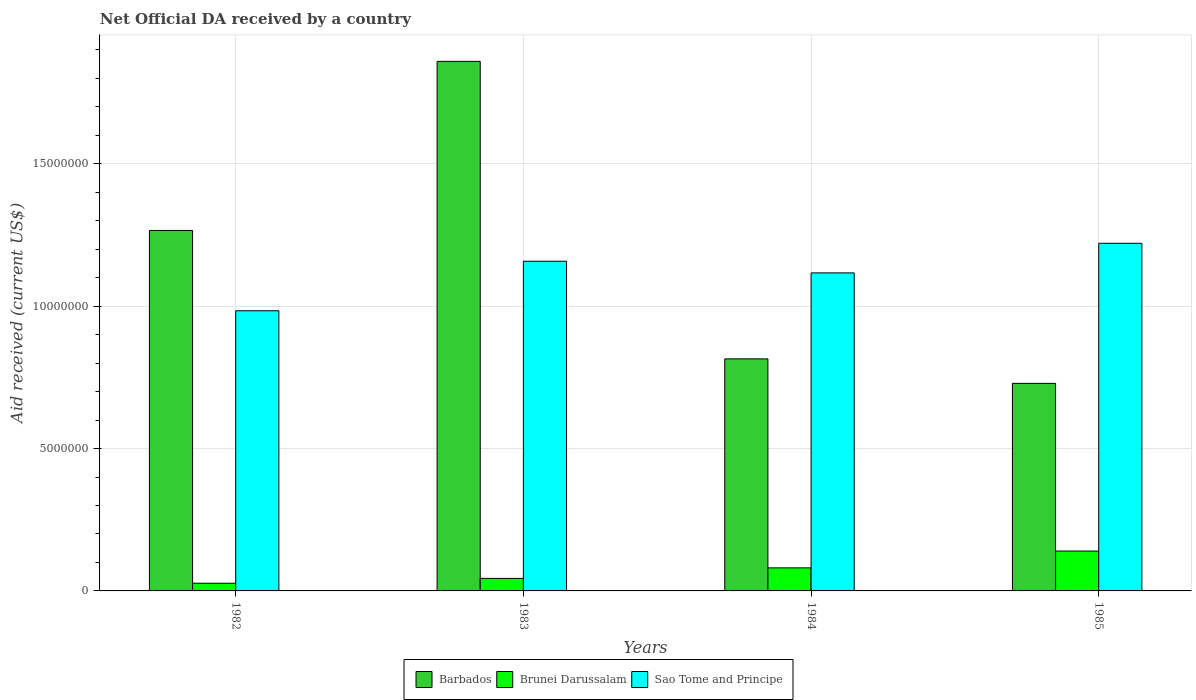How many groups of bars are there?
Provide a short and direct response. 4. Are the number of bars on each tick of the X-axis equal?
Offer a very short reply. Yes. What is the net official development assistance aid received in Brunei Darussalam in 1985?
Provide a short and direct response. 1.40e+06. Across all years, what is the maximum net official development assistance aid received in Brunei Darussalam?
Keep it short and to the point. 1.40e+06. Across all years, what is the minimum net official development assistance aid received in Barbados?
Give a very brief answer. 7.29e+06. In which year was the net official development assistance aid received in Barbados maximum?
Ensure brevity in your answer.  1983. In which year was the net official development assistance aid received in Barbados minimum?
Your answer should be very brief. 1985. What is the total net official development assistance aid received in Sao Tome and Principe in the graph?
Provide a short and direct response. 4.48e+07. What is the difference between the net official development assistance aid received in Brunei Darussalam in 1983 and that in 1984?
Ensure brevity in your answer.  -3.70e+05. What is the difference between the net official development assistance aid received in Sao Tome and Principe in 1982 and the net official development assistance aid received in Barbados in 1984?
Offer a very short reply. 1.69e+06. What is the average net official development assistance aid received in Brunei Darussalam per year?
Ensure brevity in your answer.  7.30e+05. In the year 1983, what is the difference between the net official development assistance aid received in Brunei Darussalam and net official development assistance aid received in Sao Tome and Principe?
Provide a short and direct response. -1.11e+07. In how many years, is the net official development assistance aid received in Barbados greater than 14000000 US$?
Your answer should be compact. 1. What is the ratio of the net official development assistance aid received in Barbados in 1984 to that in 1985?
Ensure brevity in your answer.  1.12. Is the net official development assistance aid received in Barbados in 1982 less than that in 1983?
Offer a very short reply. Yes. What is the difference between the highest and the second highest net official development assistance aid received in Brunei Darussalam?
Offer a terse response. 5.90e+05. What is the difference between the highest and the lowest net official development assistance aid received in Brunei Darussalam?
Give a very brief answer. 1.13e+06. What does the 2nd bar from the left in 1983 represents?
Provide a succinct answer. Brunei Darussalam. What does the 3rd bar from the right in 1985 represents?
Your response must be concise. Barbados. How many bars are there?
Your answer should be compact. 12. Are all the bars in the graph horizontal?
Offer a terse response. No. How many years are there in the graph?
Your answer should be compact. 4. What is the difference between two consecutive major ticks on the Y-axis?
Your response must be concise. 5.00e+06. Does the graph contain any zero values?
Offer a very short reply. No. Does the graph contain grids?
Keep it short and to the point. Yes. Where does the legend appear in the graph?
Your answer should be very brief. Bottom center. What is the title of the graph?
Your answer should be compact. Net Official DA received by a country. Does "San Marino" appear as one of the legend labels in the graph?
Provide a succinct answer. No. What is the label or title of the Y-axis?
Your response must be concise. Aid received (current US$). What is the Aid received (current US$) of Barbados in 1982?
Your answer should be compact. 1.27e+07. What is the Aid received (current US$) in Sao Tome and Principe in 1982?
Give a very brief answer. 9.84e+06. What is the Aid received (current US$) in Barbados in 1983?
Give a very brief answer. 1.86e+07. What is the Aid received (current US$) in Brunei Darussalam in 1983?
Offer a terse response. 4.40e+05. What is the Aid received (current US$) in Sao Tome and Principe in 1983?
Provide a succinct answer. 1.16e+07. What is the Aid received (current US$) of Barbados in 1984?
Your response must be concise. 8.15e+06. What is the Aid received (current US$) in Brunei Darussalam in 1984?
Offer a terse response. 8.10e+05. What is the Aid received (current US$) in Sao Tome and Principe in 1984?
Provide a succinct answer. 1.12e+07. What is the Aid received (current US$) in Barbados in 1985?
Provide a short and direct response. 7.29e+06. What is the Aid received (current US$) in Brunei Darussalam in 1985?
Your answer should be very brief. 1.40e+06. What is the Aid received (current US$) of Sao Tome and Principe in 1985?
Make the answer very short. 1.22e+07. Across all years, what is the maximum Aid received (current US$) of Barbados?
Provide a succinct answer. 1.86e+07. Across all years, what is the maximum Aid received (current US$) of Brunei Darussalam?
Give a very brief answer. 1.40e+06. Across all years, what is the maximum Aid received (current US$) of Sao Tome and Principe?
Your answer should be very brief. 1.22e+07. Across all years, what is the minimum Aid received (current US$) of Barbados?
Provide a succinct answer. 7.29e+06. Across all years, what is the minimum Aid received (current US$) in Brunei Darussalam?
Keep it short and to the point. 2.70e+05. Across all years, what is the minimum Aid received (current US$) of Sao Tome and Principe?
Provide a succinct answer. 9.84e+06. What is the total Aid received (current US$) in Barbados in the graph?
Your answer should be compact. 4.67e+07. What is the total Aid received (current US$) of Brunei Darussalam in the graph?
Give a very brief answer. 2.92e+06. What is the total Aid received (current US$) in Sao Tome and Principe in the graph?
Keep it short and to the point. 4.48e+07. What is the difference between the Aid received (current US$) in Barbados in 1982 and that in 1983?
Give a very brief answer. -5.94e+06. What is the difference between the Aid received (current US$) in Brunei Darussalam in 1982 and that in 1983?
Ensure brevity in your answer.  -1.70e+05. What is the difference between the Aid received (current US$) of Sao Tome and Principe in 1982 and that in 1983?
Offer a very short reply. -1.74e+06. What is the difference between the Aid received (current US$) in Barbados in 1982 and that in 1984?
Offer a very short reply. 4.51e+06. What is the difference between the Aid received (current US$) of Brunei Darussalam in 1982 and that in 1984?
Ensure brevity in your answer.  -5.40e+05. What is the difference between the Aid received (current US$) in Sao Tome and Principe in 1982 and that in 1984?
Provide a short and direct response. -1.33e+06. What is the difference between the Aid received (current US$) in Barbados in 1982 and that in 1985?
Give a very brief answer. 5.37e+06. What is the difference between the Aid received (current US$) in Brunei Darussalam in 1982 and that in 1985?
Keep it short and to the point. -1.13e+06. What is the difference between the Aid received (current US$) in Sao Tome and Principe in 1982 and that in 1985?
Provide a succinct answer. -2.37e+06. What is the difference between the Aid received (current US$) of Barbados in 1983 and that in 1984?
Provide a short and direct response. 1.04e+07. What is the difference between the Aid received (current US$) of Brunei Darussalam in 1983 and that in 1984?
Provide a succinct answer. -3.70e+05. What is the difference between the Aid received (current US$) of Barbados in 1983 and that in 1985?
Your response must be concise. 1.13e+07. What is the difference between the Aid received (current US$) of Brunei Darussalam in 1983 and that in 1985?
Provide a succinct answer. -9.60e+05. What is the difference between the Aid received (current US$) in Sao Tome and Principe in 1983 and that in 1985?
Give a very brief answer. -6.30e+05. What is the difference between the Aid received (current US$) of Barbados in 1984 and that in 1985?
Offer a very short reply. 8.60e+05. What is the difference between the Aid received (current US$) of Brunei Darussalam in 1984 and that in 1985?
Offer a very short reply. -5.90e+05. What is the difference between the Aid received (current US$) of Sao Tome and Principe in 1984 and that in 1985?
Your response must be concise. -1.04e+06. What is the difference between the Aid received (current US$) in Barbados in 1982 and the Aid received (current US$) in Brunei Darussalam in 1983?
Provide a short and direct response. 1.22e+07. What is the difference between the Aid received (current US$) in Barbados in 1982 and the Aid received (current US$) in Sao Tome and Principe in 1983?
Your response must be concise. 1.08e+06. What is the difference between the Aid received (current US$) in Brunei Darussalam in 1982 and the Aid received (current US$) in Sao Tome and Principe in 1983?
Give a very brief answer. -1.13e+07. What is the difference between the Aid received (current US$) in Barbados in 1982 and the Aid received (current US$) in Brunei Darussalam in 1984?
Your response must be concise. 1.18e+07. What is the difference between the Aid received (current US$) in Barbados in 1982 and the Aid received (current US$) in Sao Tome and Principe in 1984?
Your answer should be very brief. 1.49e+06. What is the difference between the Aid received (current US$) of Brunei Darussalam in 1982 and the Aid received (current US$) of Sao Tome and Principe in 1984?
Offer a very short reply. -1.09e+07. What is the difference between the Aid received (current US$) in Barbados in 1982 and the Aid received (current US$) in Brunei Darussalam in 1985?
Provide a short and direct response. 1.13e+07. What is the difference between the Aid received (current US$) of Barbados in 1982 and the Aid received (current US$) of Sao Tome and Principe in 1985?
Offer a very short reply. 4.50e+05. What is the difference between the Aid received (current US$) of Brunei Darussalam in 1982 and the Aid received (current US$) of Sao Tome and Principe in 1985?
Offer a very short reply. -1.19e+07. What is the difference between the Aid received (current US$) of Barbados in 1983 and the Aid received (current US$) of Brunei Darussalam in 1984?
Give a very brief answer. 1.78e+07. What is the difference between the Aid received (current US$) in Barbados in 1983 and the Aid received (current US$) in Sao Tome and Principe in 1984?
Give a very brief answer. 7.43e+06. What is the difference between the Aid received (current US$) of Brunei Darussalam in 1983 and the Aid received (current US$) of Sao Tome and Principe in 1984?
Give a very brief answer. -1.07e+07. What is the difference between the Aid received (current US$) of Barbados in 1983 and the Aid received (current US$) of Brunei Darussalam in 1985?
Ensure brevity in your answer.  1.72e+07. What is the difference between the Aid received (current US$) in Barbados in 1983 and the Aid received (current US$) in Sao Tome and Principe in 1985?
Your response must be concise. 6.39e+06. What is the difference between the Aid received (current US$) of Brunei Darussalam in 1983 and the Aid received (current US$) of Sao Tome and Principe in 1985?
Make the answer very short. -1.18e+07. What is the difference between the Aid received (current US$) in Barbados in 1984 and the Aid received (current US$) in Brunei Darussalam in 1985?
Your answer should be very brief. 6.75e+06. What is the difference between the Aid received (current US$) of Barbados in 1984 and the Aid received (current US$) of Sao Tome and Principe in 1985?
Offer a very short reply. -4.06e+06. What is the difference between the Aid received (current US$) in Brunei Darussalam in 1984 and the Aid received (current US$) in Sao Tome and Principe in 1985?
Ensure brevity in your answer.  -1.14e+07. What is the average Aid received (current US$) in Barbados per year?
Offer a very short reply. 1.17e+07. What is the average Aid received (current US$) of Brunei Darussalam per year?
Keep it short and to the point. 7.30e+05. What is the average Aid received (current US$) of Sao Tome and Principe per year?
Your answer should be compact. 1.12e+07. In the year 1982, what is the difference between the Aid received (current US$) in Barbados and Aid received (current US$) in Brunei Darussalam?
Keep it short and to the point. 1.24e+07. In the year 1982, what is the difference between the Aid received (current US$) in Barbados and Aid received (current US$) in Sao Tome and Principe?
Offer a very short reply. 2.82e+06. In the year 1982, what is the difference between the Aid received (current US$) in Brunei Darussalam and Aid received (current US$) in Sao Tome and Principe?
Your response must be concise. -9.57e+06. In the year 1983, what is the difference between the Aid received (current US$) of Barbados and Aid received (current US$) of Brunei Darussalam?
Your answer should be compact. 1.82e+07. In the year 1983, what is the difference between the Aid received (current US$) in Barbados and Aid received (current US$) in Sao Tome and Principe?
Your answer should be very brief. 7.02e+06. In the year 1983, what is the difference between the Aid received (current US$) of Brunei Darussalam and Aid received (current US$) of Sao Tome and Principe?
Your response must be concise. -1.11e+07. In the year 1984, what is the difference between the Aid received (current US$) of Barbados and Aid received (current US$) of Brunei Darussalam?
Offer a terse response. 7.34e+06. In the year 1984, what is the difference between the Aid received (current US$) in Barbados and Aid received (current US$) in Sao Tome and Principe?
Your answer should be very brief. -3.02e+06. In the year 1984, what is the difference between the Aid received (current US$) of Brunei Darussalam and Aid received (current US$) of Sao Tome and Principe?
Your response must be concise. -1.04e+07. In the year 1985, what is the difference between the Aid received (current US$) of Barbados and Aid received (current US$) of Brunei Darussalam?
Your response must be concise. 5.89e+06. In the year 1985, what is the difference between the Aid received (current US$) of Barbados and Aid received (current US$) of Sao Tome and Principe?
Give a very brief answer. -4.92e+06. In the year 1985, what is the difference between the Aid received (current US$) in Brunei Darussalam and Aid received (current US$) in Sao Tome and Principe?
Your answer should be very brief. -1.08e+07. What is the ratio of the Aid received (current US$) of Barbados in 1982 to that in 1983?
Offer a terse response. 0.68. What is the ratio of the Aid received (current US$) of Brunei Darussalam in 1982 to that in 1983?
Provide a short and direct response. 0.61. What is the ratio of the Aid received (current US$) in Sao Tome and Principe in 1982 to that in 1983?
Provide a succinct answer. 0.85. What is the ratio of the Aid received (current US$) of Barbados in 1982 to that in 1984?
Your response must be concise. 1.55. What is the ratio of the Aid received (current US$) of Sao Tome and Principe in 1982 to that in 1984?
Provide a short and direct response. 0.88. What is the ratio of the Aid received (current US$) of Barbados in 1982 to that in 1985?
Offer a terse response. 1.74. What is the ratio of the Aid received (current US$) in Brunei Darussalam in 1982 to that in 1985?
Keep it short and to the point. 0.19. What is the ratio of the Aid received (current US$) in Sao Tome and Principe in 1982 to that in 1985?
Your answer should be very brief. 0.81. What is the ratio of the Aid received (current US$) of Barbados in 1983 to that in 1984?
Your answer should be compact. 2.28. What is the ratio of the Aid received (current US$) in Brunei Darussalam in 1983 to that in 1984?
Make the answer very short. 0.54. What is the ratio of the Aid received (current US$) of Sao Tome and Principe in 1983 to that in 1984?
Provide a short and direct response. 1.04. What is the ratio of the Aid received (current US$) in Barbados in 1983 to that in 1985?
Ensure brevity in your answer.  2.55. What is the ratio of the Aid received (current US$) of Brunei Darussalam in 1983 to that in 1985?
Provide a short and direct response. 0.31. What is the ratio of the Aid received (current US$) of Sao Tome and Principe in 1983 to that in 1985?
Ensure brevity in your answer.  0.95. What is the ratio of the Aid received (current US$) in Barbados in 1984 to that in 1985?
Provide a short and direct response. 1.12. What is the ratio of the Aid received (current US$) of Brunei Darussalam in 1984 to that in 1985?
Offer a terse response. 0.58. What is the ratio of the Aid received (current US$) of Sao Tome and Principe in 1984 to that in 1985?
Give a very brief answer. 0.91. What is the difference between the highest and the second highest Aid received (current US$) in Barbados?
Offer a very short reply. 5.94e+06. What is the difference between the highest and the second highest Aid received (current US$) in Brunei Darussalam?
Offer a terse response. 5.90e+05. What is the difference between the highest and the second highest Aid received (current US$) in Sao Tome and Principe?
Your answer should be very brief. 6.30e+05. What is the difference between the highest and the lowest Aid received (current US$) of Barbados?
Provide a succinct answer. 1.13e+07. What is the difference between the highest and the lowest Aid received (current US$) of Brunei Darussalam?
Keep it short and to the point. 1.13e+06. What is the difference between the highest and the lowest Aid received (current US$) of Sao Tome and Principe?
Make the answer very short. 2.37e+06. 